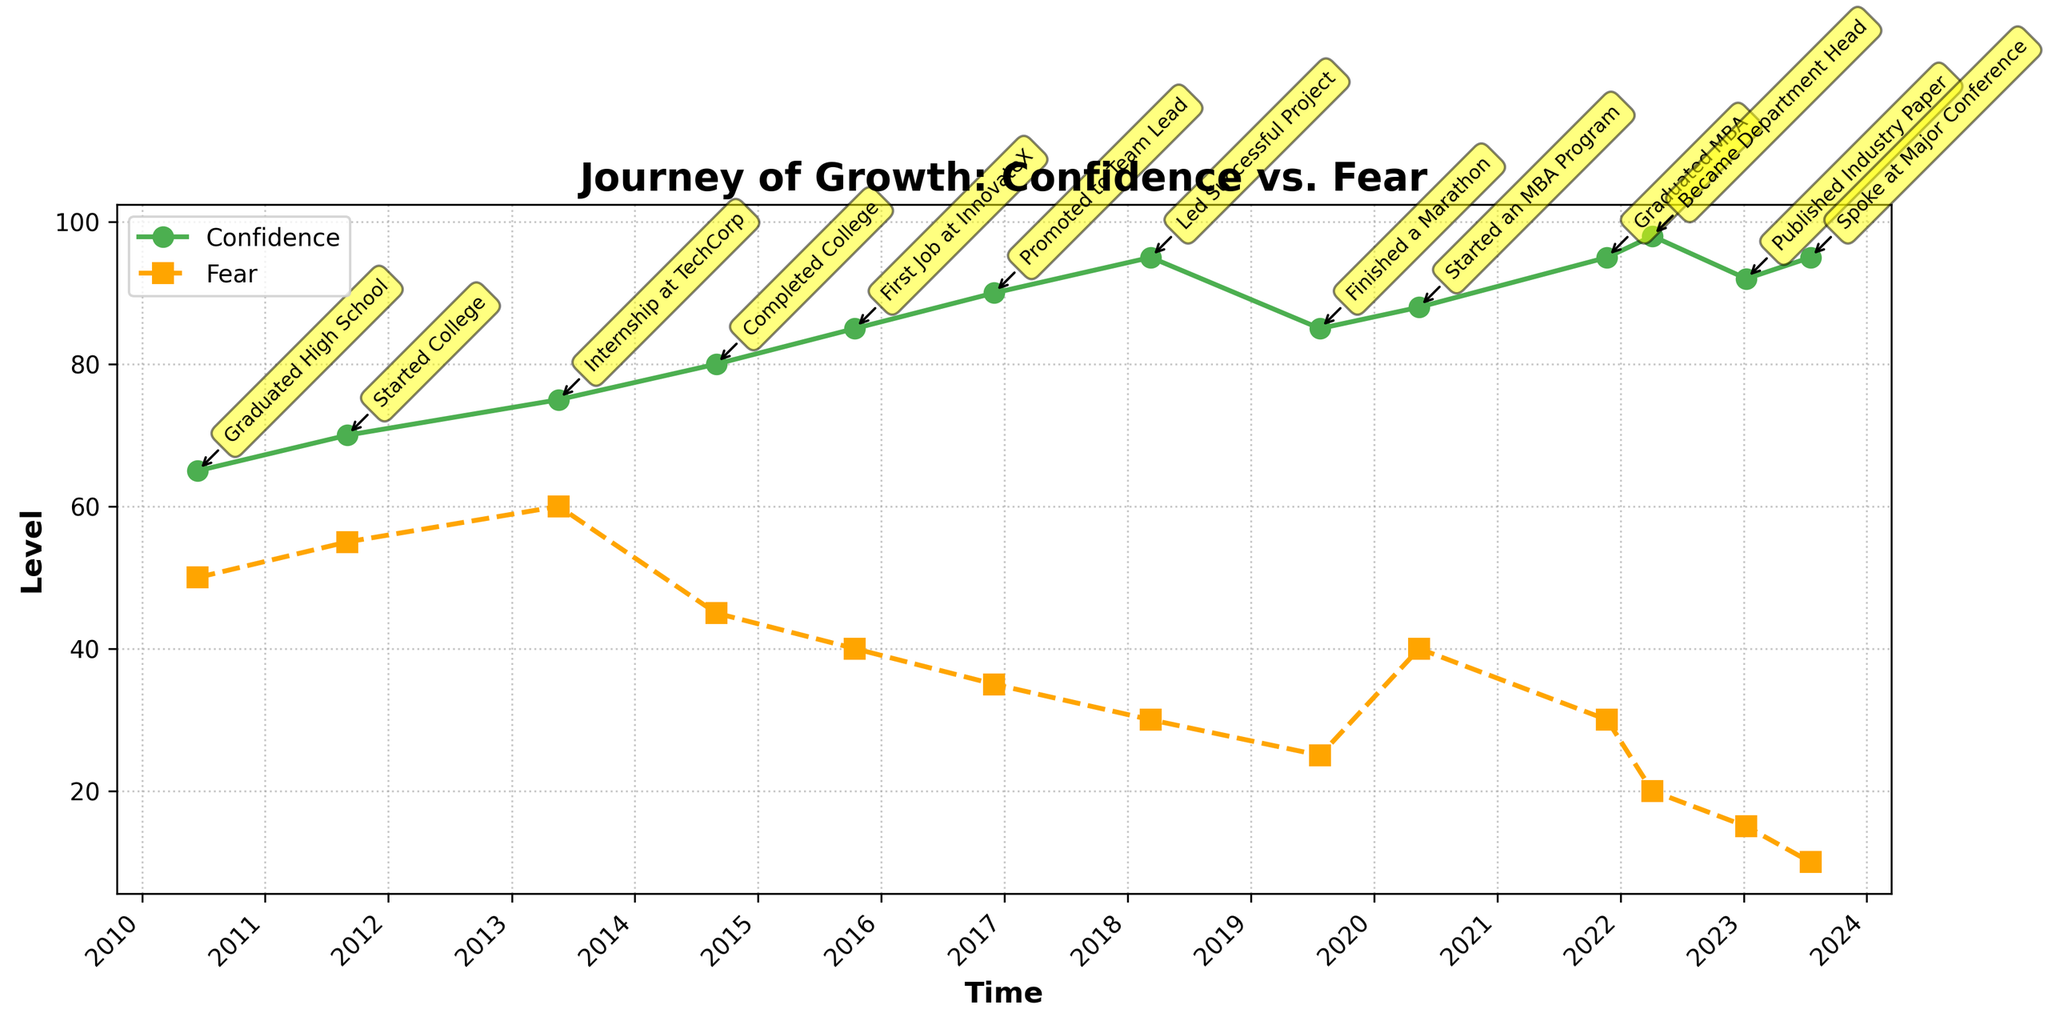What is the title of the plot? The title is located at the top center of the plot and is written in a bold, larger font. It directly describes the theme of the plot, which is about the relationship between Confidence and Fear over time.
Answer: Journey of Growth: Confidence vs. Fear Which axis represents time? The x-axis at the bottom of the plot represents time, as indicated by the xlabel "Time" and the dates labeled along this axis.
Answer: x-axis How many achievements are annotated in the plot? By counting the number of annotations (yellow boxes with text) placed along the lines, you can determine the number of achievements. Each box represents a significant career milestone.
Answer: 13 Compare the levels of Confidence and Fear in 2016. Which one is higher and by how much? Find the data points for 2016 on the plot. The Confidence level in 2016 is around 90, whereas the Fear level is approximately 35. Calculate the difference by subtracting 35 from 90.
Answer: Confidence is higher by 55 What is the trend of Fear levels from 2010 to 2023? Observe the dashed line representing Fear levels over the years. Starting at 50 in 2010, it generally decreases with slight fluctuations, reaching a low of 10 in 2023.
Answer: Decreasing During which year did Confidence see the maximum increase? By analyzing the steepness of the solid line, the maximum upward slope indicates the largest increase in Confidence. Compare the changes year by year.
Answer: 2010 to 2011 Which achievement corresponds with the highest level of fear recorded in the plot? Look for the annotation closest to the peak of the dashed Fear line. The highest recorded Fear level around 2013 coincides with the "Internship at TechCorp" annotation.
Answer: Internship at TechCorp On average, how does the Confidence level change after each achievement from 2010 to 2023? Compute the difference in Confidence levels between consecutive achievements and find the average change. This involves multiple addition and division steps. Use the listed Confidence values and refer to their changes over time.
Answer: Average increase per achievement What is the lowest level of Confidence recorded, and when did it occur? Identify the lowest point on the solid Confidence line and refer to the corresponding date and label. The graph shows the lowest point around 90 in the early years.
Answer: 65 in 2010 Is there a correlation between Confidence and Fear levels? If so, describe it. Analyze the general trends and relationships between the solid (Confidence) and dashed (Fear) lines. As Confidence increases, Fear typically decreases, indicating an inverse correlation.
Answer: Inverse correlation 